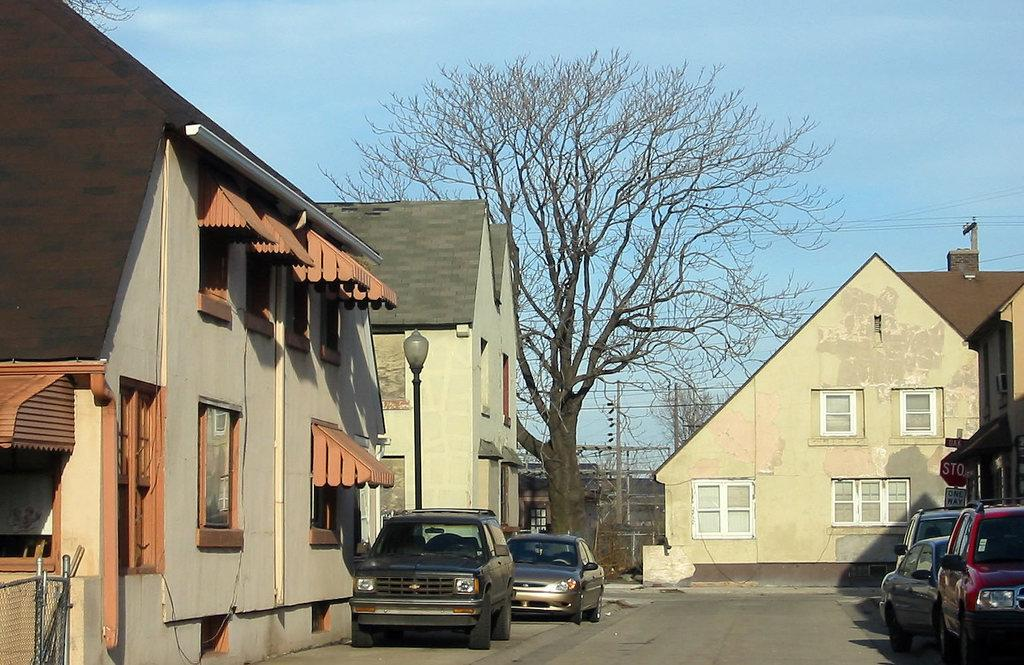What can be seen in the image that moves on roads? There are vehicles in the image. What colors are the buildings in the image? The buildings in the image are in brown and cream colors. What is the tall, vertical structure in the image? There is a light pole in the image. What type of vegetation is visible in the background of the image? There are dried trees in the background of the image. What color is the sky in the image? The sky is blue in the image. What type of canvas is used to create the prison in the image? There is no prison present in the image, and therefore no canvas can be associated with it. 